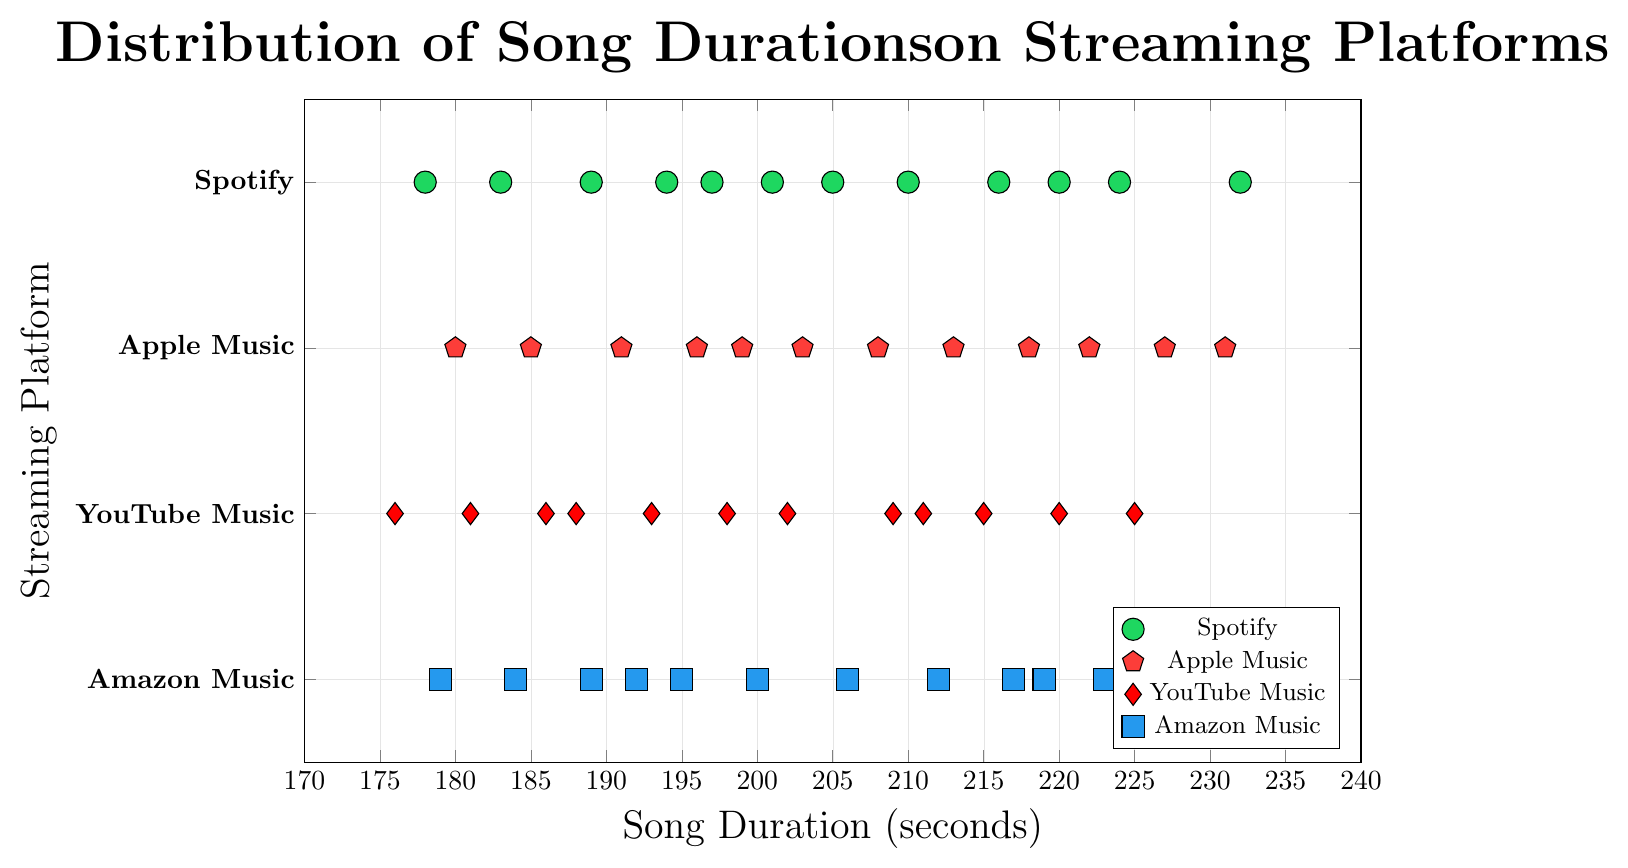Which platform has the longest song duration? The longest song duration can be identified by finding the maximum value on the x-axis for each platform and comparing them. The maximum values are 232s (Spotify), 231s (Apple Music), 225s (YouTube Music), and 228s (Amazon Music). Among these, 232s is the highest.
Answer: Spotify Which platform has the shortest song duration? The shortest song duration can be identified by finding the minimum value on the x-axis for each platform and comparing them. The minimum values are 178s (Spotify), 180s (Apple Music), 176s (YouTube Music), and 179s (Amazon Music). Among these, 176s is the lowest.
Answer: YouTube Music What is the range of song durations on Spotify? The range is calculated by subtracting the minimum value from the maximum value on Spotify's x-axis, which are 232s and 178s respectively: 232 - 178 = 54.
Answer: 54 Which platform has the most clustered song durations around the median? To determine this, look at the spread of the dots along the x-axis for each platform. Apple Music has song durations closely clustered around the median (208s, 213s, 218s, 222s).
Answer: Apple Music What is the average song duration on Apple Music? Add up all the song durations on Apple Music and divide by the number of songs: (185 + 208 + 196 + 222 + 180 + 213 + 199 + 227 + 191 + 218 + 203 + 231) / 12 = 2153 / 12 ≈ 179.1.
Answer: 179.1 How do YouTube Music's song durations compare to Amazon Music's? Compare the spread and central tendency (mean, median) of song durations. YouTube Music's durations range from 176s to 225s, while Amazon Music ranges from 179s to 228s. YouTube Music’s clustering is more centralized around the lower 200s.
Answer: YouTube Music has generally shorter songs What is the median song duration on Amazon Music? Median value can be found by arranging Amazon Music durations in ascending order and finding the middle value(s). Ordered: 179, 184, 189, 192, 195, 200, 206, 212, 217, 219, 223, 228. Median: (200 + 206) / 2 = 206.
Answer: 206 Which platform has the most consistent song duration distribution? Consistency can be inferred by looking at the spread. Platforms with tightly packed data points around a center are more consistent. Apple Music shows the most consistency as the points are closely packed.
Answer: Apple Music How many songs on YouTube Music are shorter than 200 seconds? Count the number of data points on YouTube Music (y=2) that lie to the left of the 200-second mark on the x-axis: 176s, 181s, 186s, 188s, 193s, 198s. There are 6 such points.
Answer: 6 Which platform has its longest song shorter than 230 seconds? By comparing the maximum song durations: Spotify (232), Apple Music (231), YouTube Music (225), Amazon Music (228), both YouTube Music and Amazon Music have maximums below 230 seconds.
Answer: YouTube Music, Amazon Music 